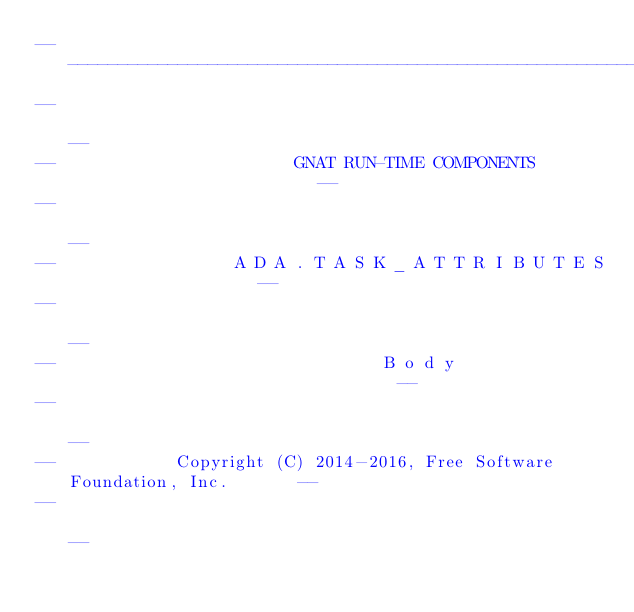<code> <loc_0><loc_0><loc_500><loc_500><_Ada_>------------------------------------------------------------------------------
--                                                                          --
--                        GNAT RUN-TIME COMPONENTS                          --
--                                                                          --
--                  A D A . T A S K _ A T T R I B U T E S                   --
--                                                                          --
--                                 B o d y                                  --
--                                                                          --
--            Copyright (C) 2014-2016, Free Software Foundation, Inc.       --
--                                                                          --</code> 